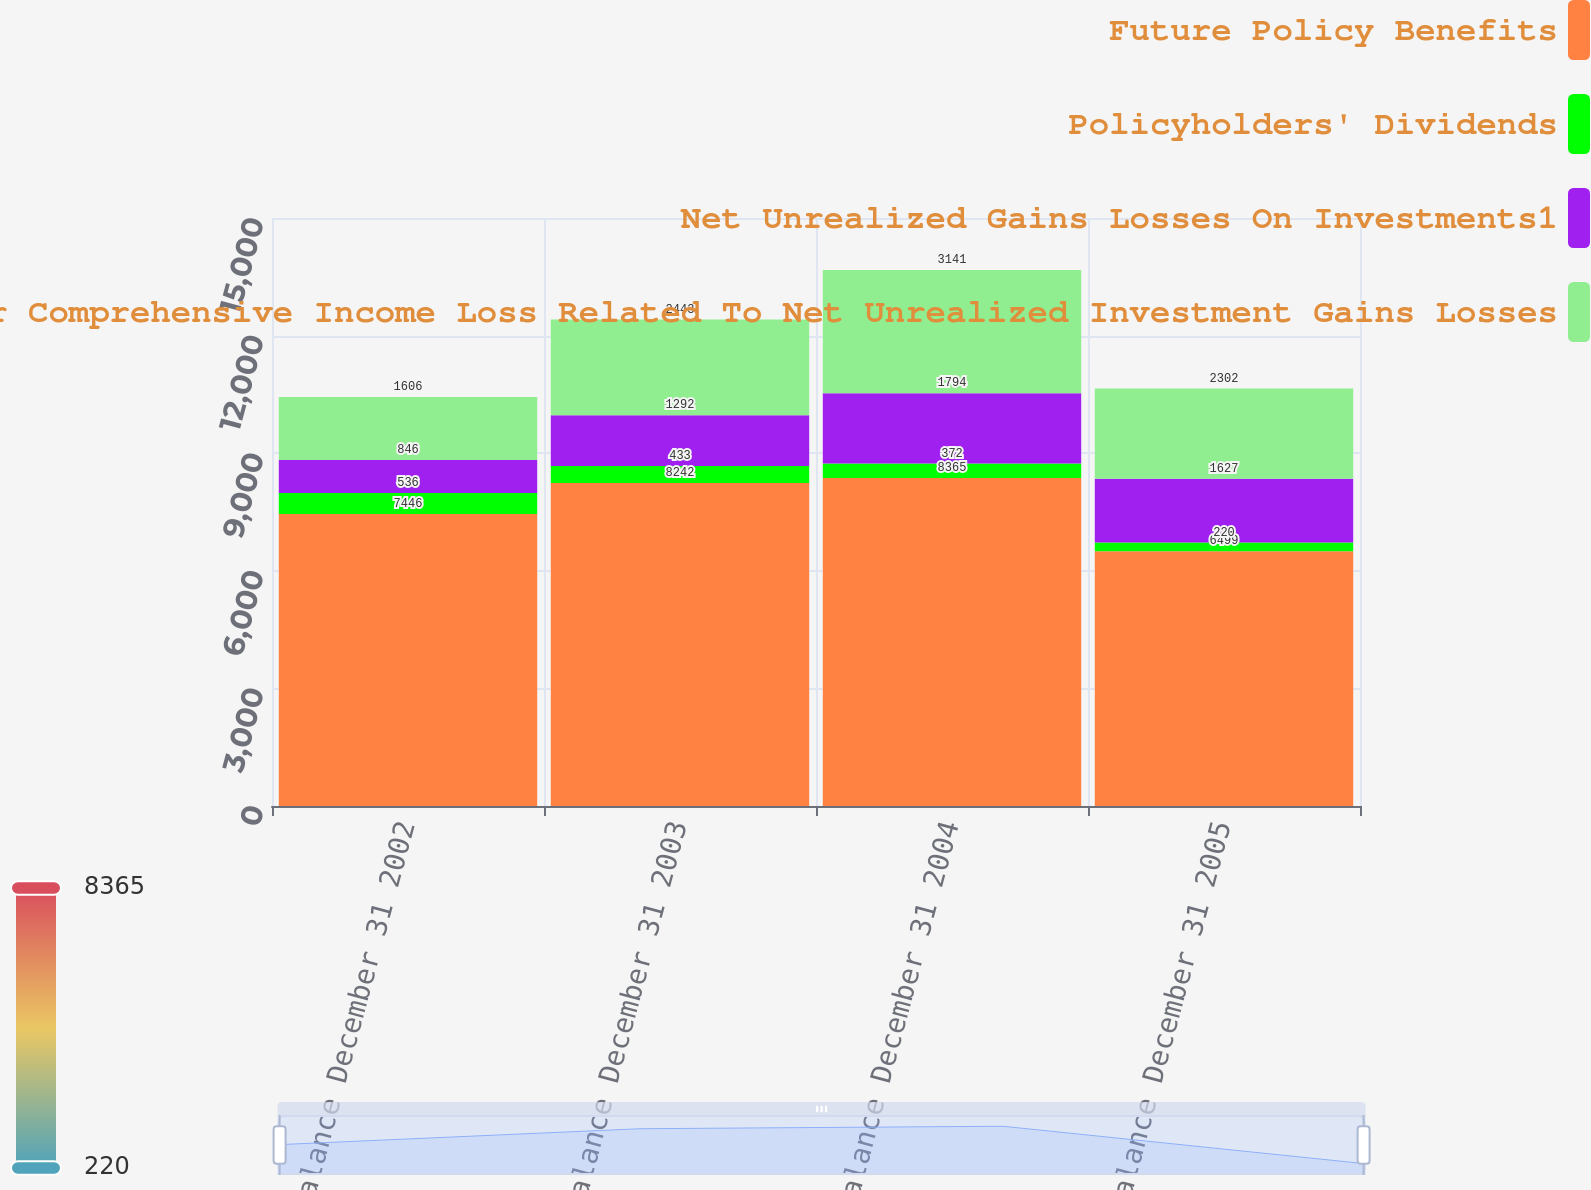<chart> <loc_0><loc_0><loc_500><loc_500><stacked_bar_chart><ecel><fcel>Balance December 31 2002<fcel>Balance December 31 2003<fcel>Balance December 31 2004<fcel>Balance December 31 2005<nl><fcel>Future Policy Benefits<fcel>7446<fcel>8242<fcel>8365<fcel>6499<nl><fcel>Policyholders' Dividends<fcel>536<fcel>433<fcel>372<fcel>220<nl><fcel>Net Unrealized Gains Losses On Investments1<fcel>846<fcel>1292<fcel>1794<fcel>1627<nl><fcel>Accumulated Other Comprehensive Income Loss Related To Net Unrealized Investment Gains Losses<fcel>1606<fcel>2443<fcel>3141<fcel>2302<nl></chart> 